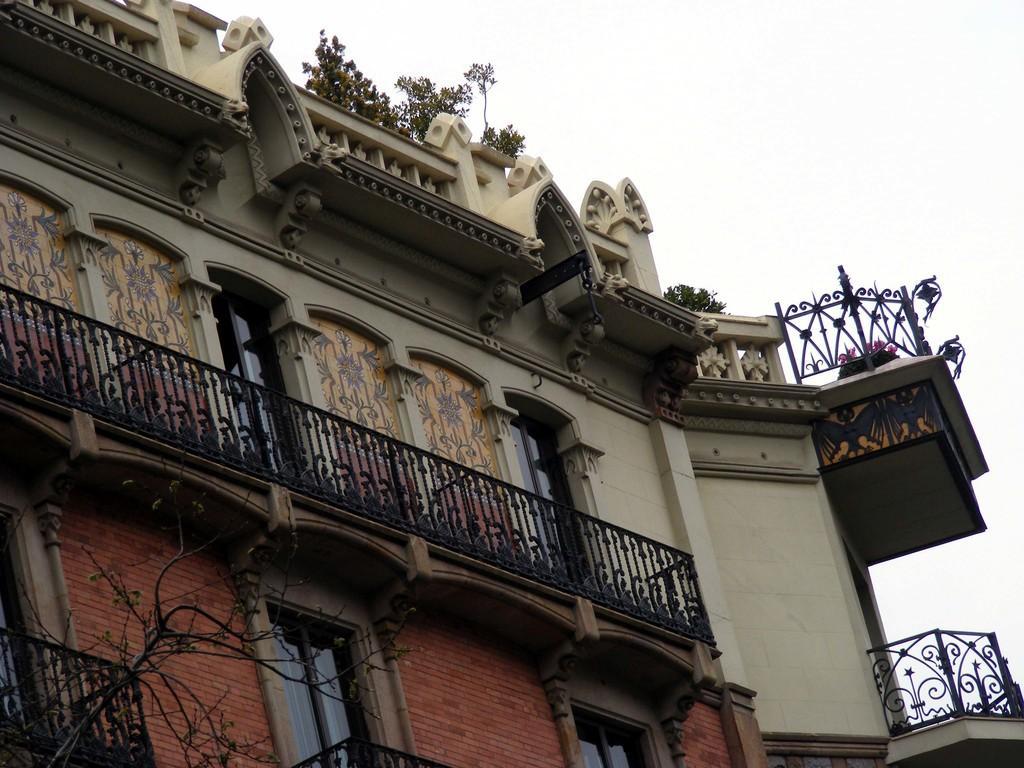In one or two sentences, can you explain what this image depicts? In this image, we can see a building with walls, windows and railings. Here we can see few plants and tree stems. Background there is a sky. 